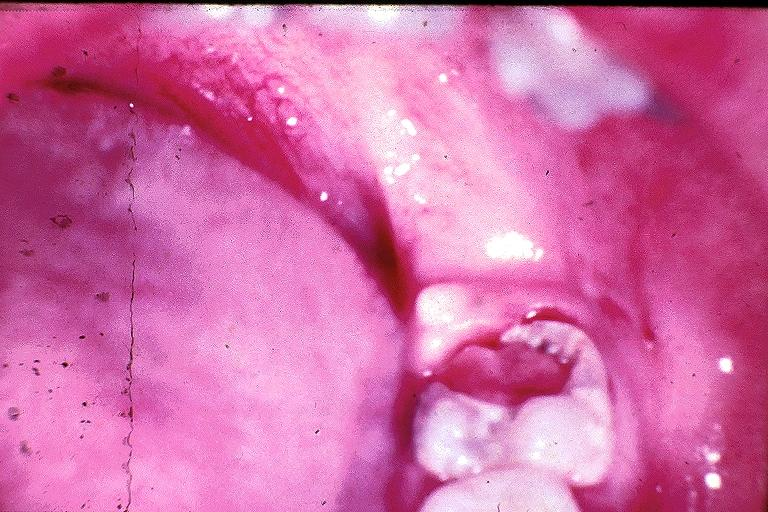s cut surface typical ivory vertebra do not have history at this time diagnosis present?
Answer the question using a single word or phrase. No 